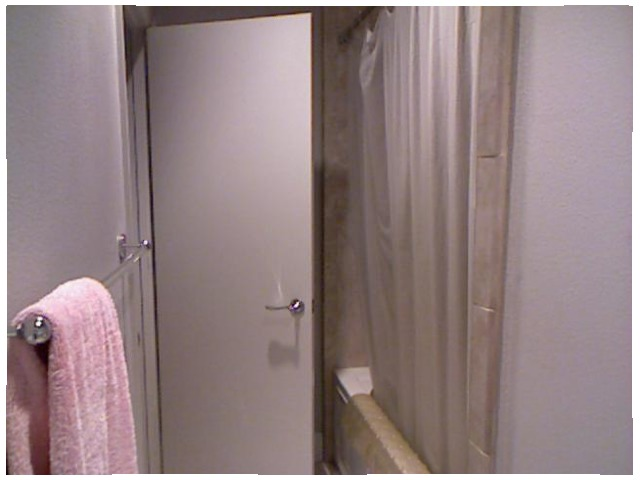<image>
Is there a towel on the door? No. The towel is not positioned on the door. They may be near each other, but the towel is not supported by or resting on top of the door. 